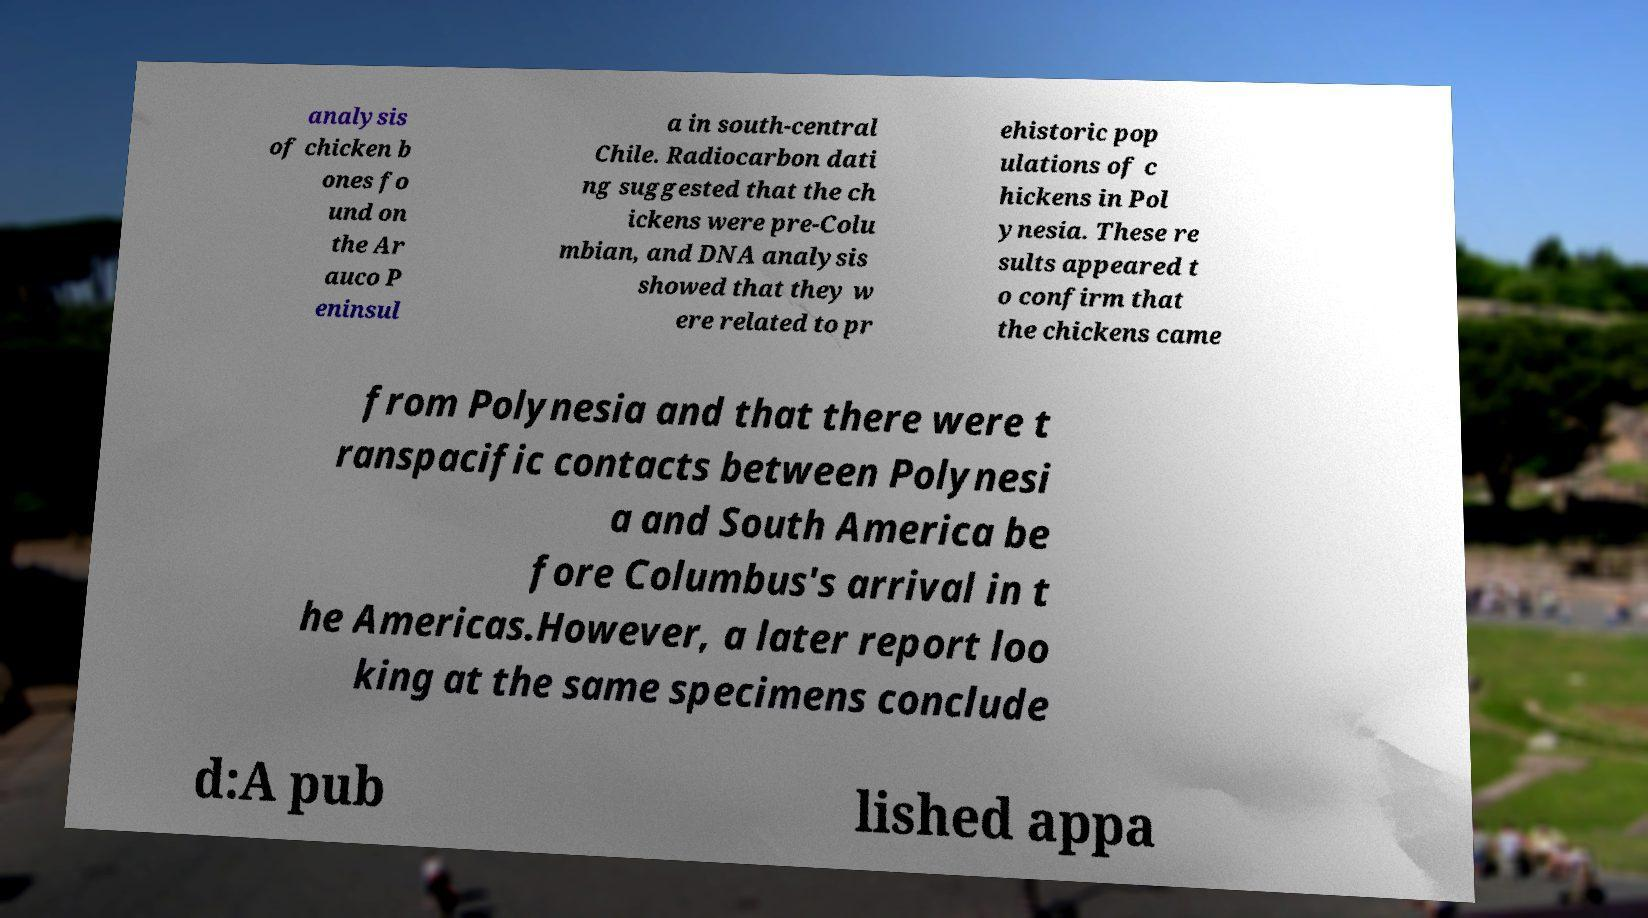There's text embedded in this image that I need extracted. Can you transcribe it verbatim? analysis of chicken b ones fo und on the Ar auco P eninsul a in south-central Chile. Radiocarbon dati ng suggested that the ch ickens were pre-Colu mbian, and DNA analysis showed that they w ere related to pr ehistoric pop ulations of c hickens in Pol ynesia. These re sults appeared t o confirm that the chickens came from Polynesia and that there were t ranspacific contacts between Polynesi a and South America be fore Columbus's arrival in t he Americas.However, a later report loo king at the same specimens conclude d:A pub lished appa 